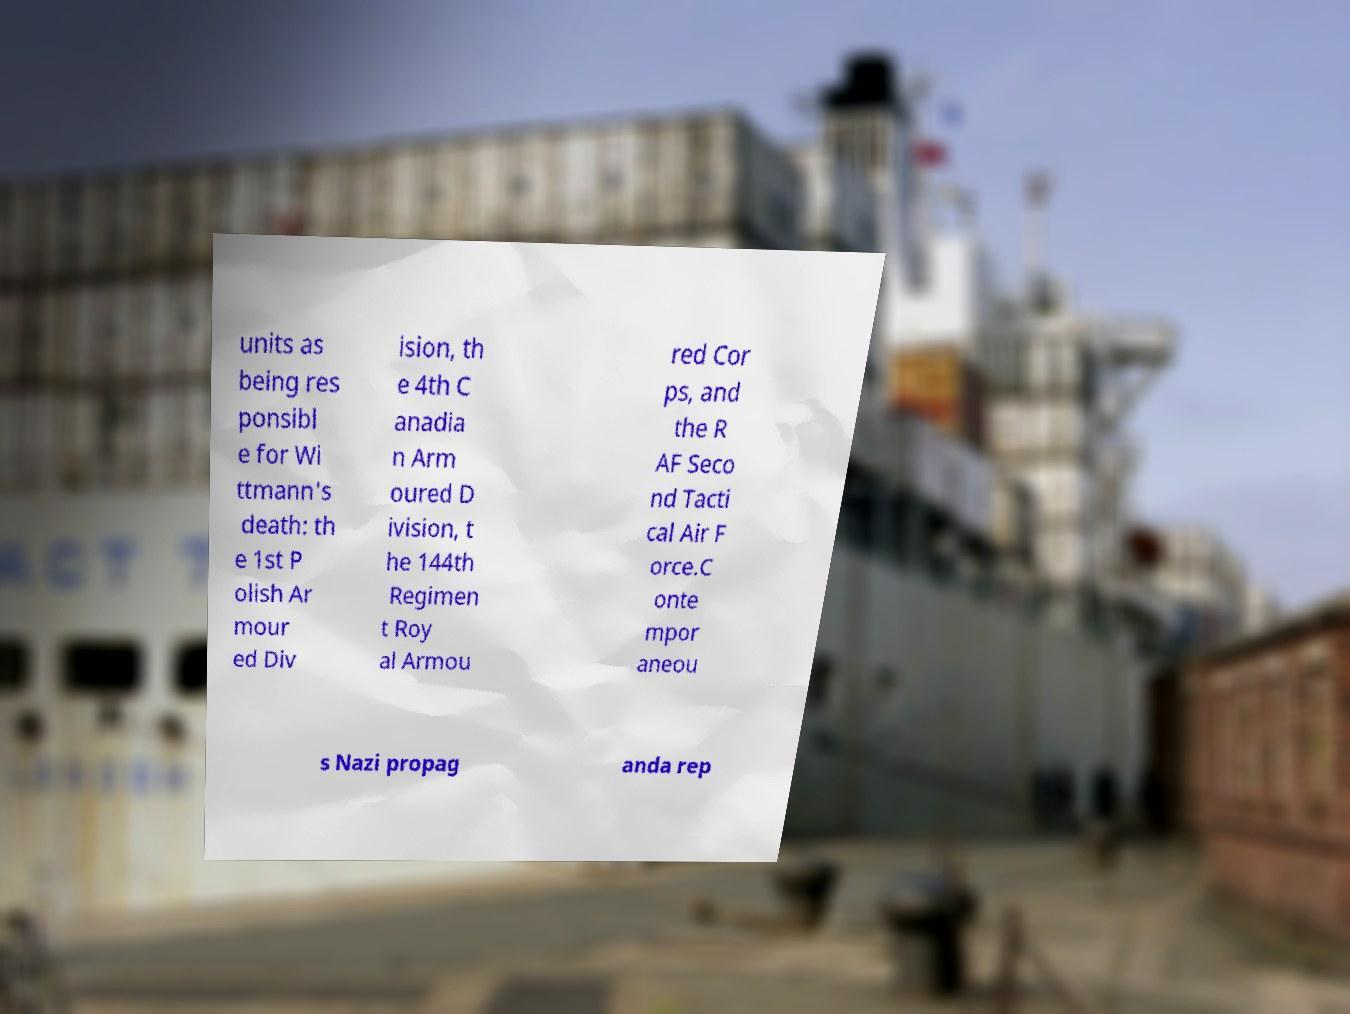Can you accurately transcribe the text from the provided image for me? units as being res ponsibl e for Wi ttmann's death: th e 1st P olish Ar mour ed Div ision, th e 4th C anadia n Arm oured D ivision, t he 144th Regimen t Roy al Armou red Cor ps, and the R AF Seco nd Tacti cal Air F orce.C onte mpor aneou s Nazi propag anda rep 